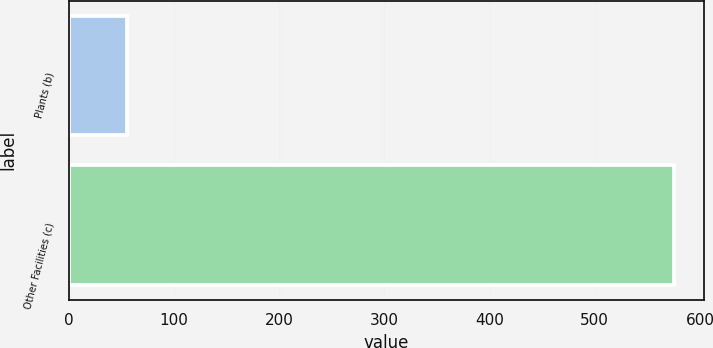Convert chart. <chart><loc_0><loc_0><loc_500><loc_500><bar_chart><fcel>Plants (b)<fcel>Other Facilities (c)<nl><fcel>55<fcel>575<nl></chart> 